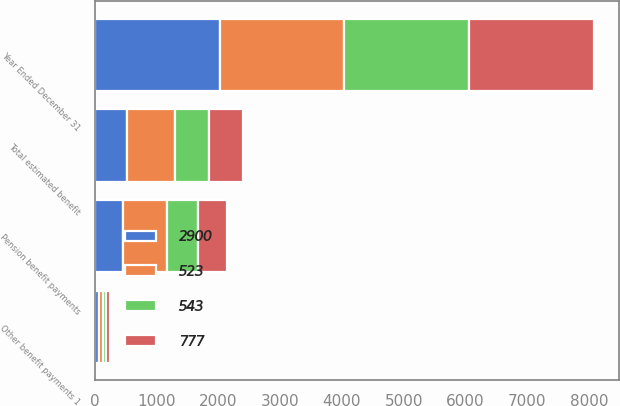Convert chart to OTSL. <chart><loc_0><loc_0><loc_500><loc_500><stacked_bar_chart><ecel><fcel>Year Ended December 31<fcel>Pension benefit payments<fcel>Other benefit payments 1<fcel>Total estimated benefit<nl><fcel>523<fcel>2018<fcel>713<fcel>64<fcel>777<nl><fcel>2900<fcel>2019<fcel>461<fcel>62<fcel>523<nl><fcel>777<fcel>2020<fcel>482<fcel>61<fcel>543<nl><fcel>543<fcel>2021<fcel>489<fcel>59<fcel>548<nl></chart> 